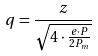Convert formula to latex. <formula><loc_0><loc_0><loc_500><loc_500>q = \frac { z } { \sqrt { 4 \cdot \frac { e \cdot P } { 2 P _ { m } } } }</formula> 